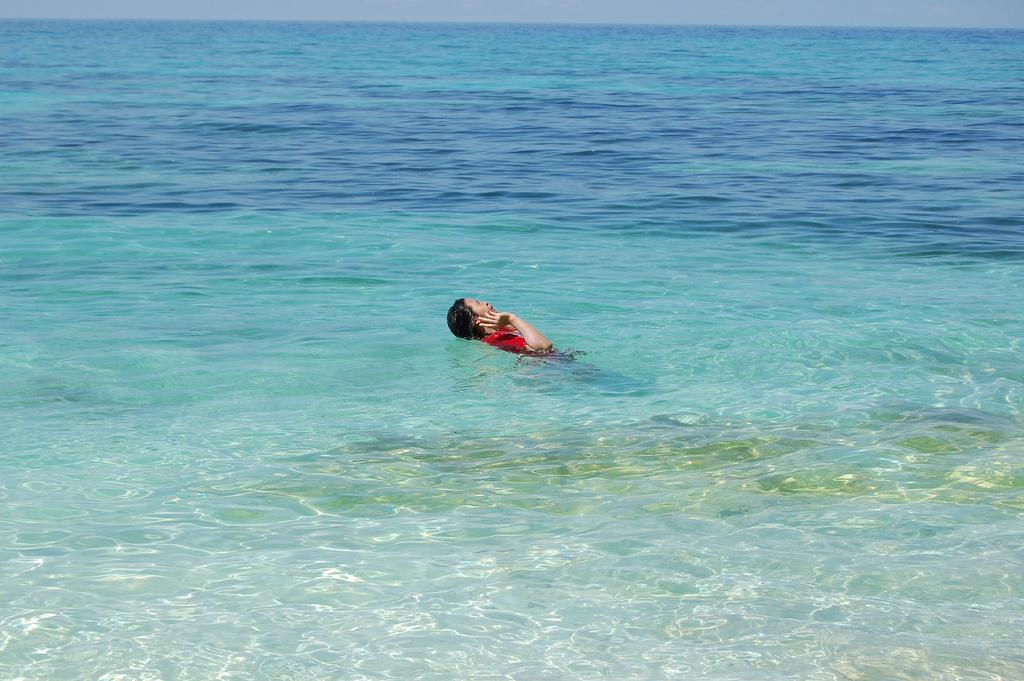Who or what is present in the image? There is a person in the image. Can you describe the person's surroundings? The person is in the water. What is the person wearing? The person is wearing a red color t-shirt. What type of blood is visible in the image? There is no blood visible in the image. What kind of air can be seen surrounding the person in the image? The image does not show any specific type of air surrounding the person. 